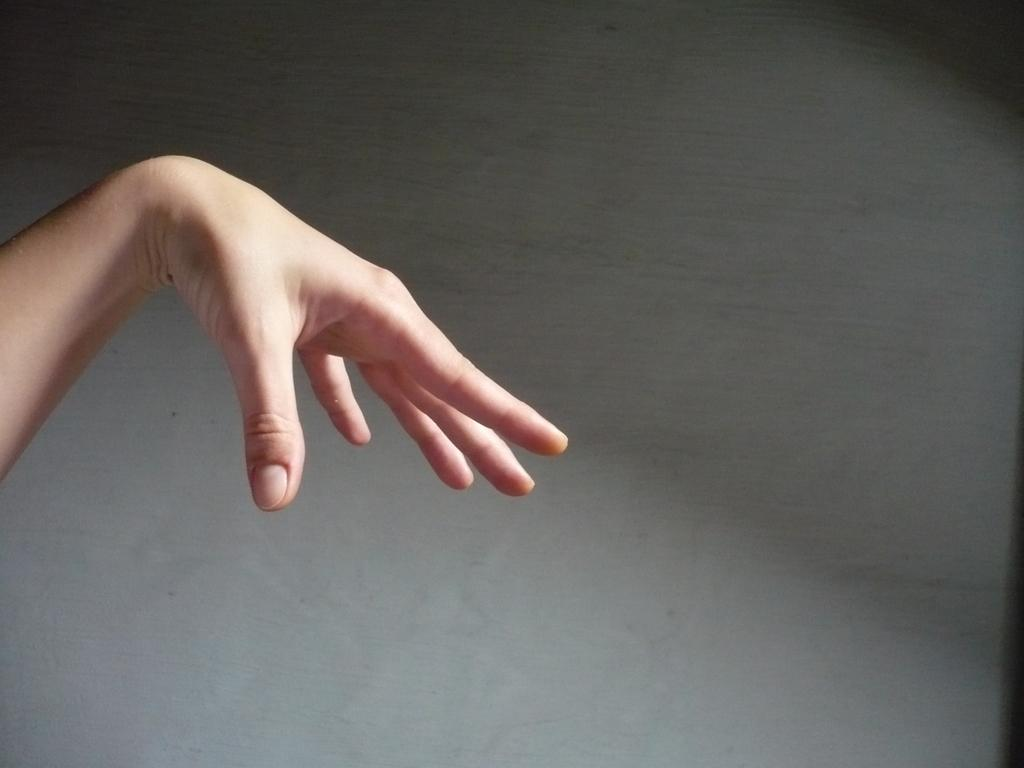What can be seen in the image? There is a person's hand in the image. What color is the background of the image? The background of the image is in ash grey color. What type of trade is being conducted in the image? There is no indication of any trade being conducted in the image, as it only shows a person's hand and the background color. 